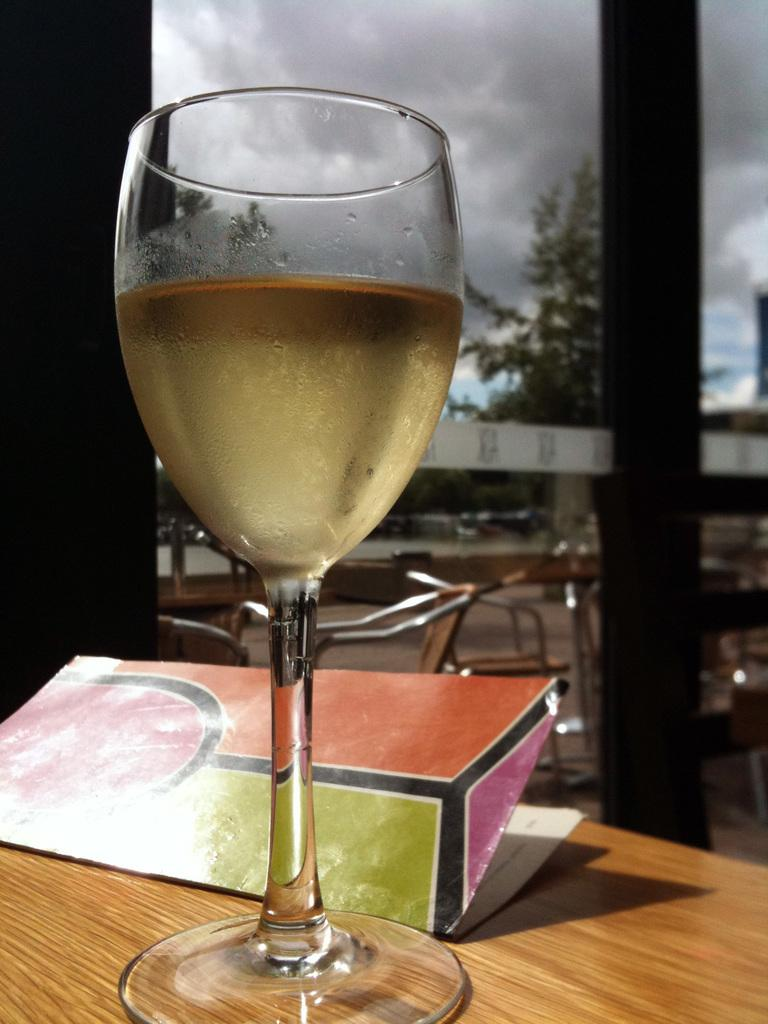What is the color of the table in the image? The table in the image is brown-colored. What is placed on the table has on it? There is a wine glass with liquid and a paper on the table. What can be seen in the background of the image? There are chairs, trees, and the sky visible in the background of the image. What type of leather is used to make the house in the image? There is no house present in the image, and therefore no leather can be associated with it. 